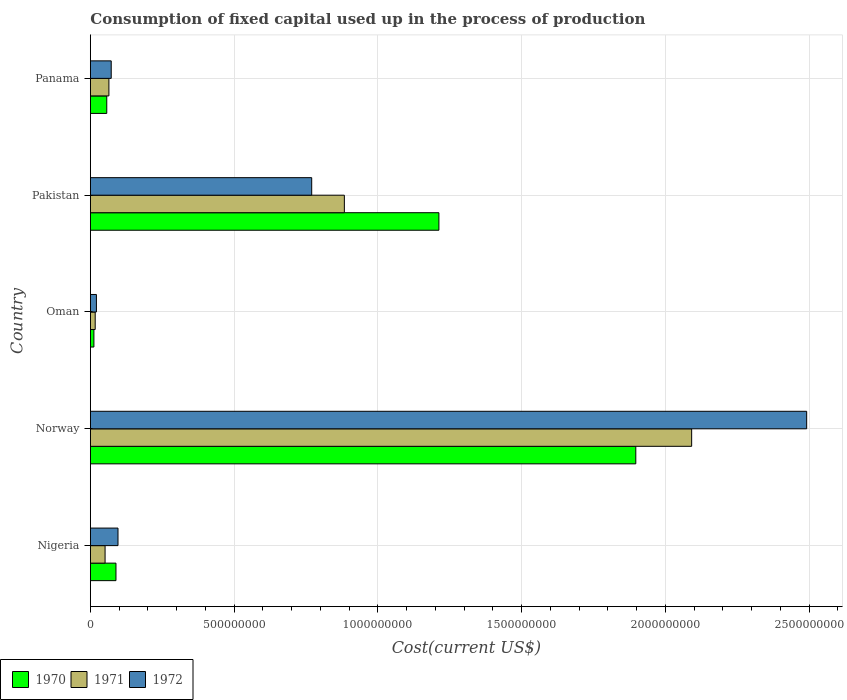How many different coloured bars are there?
Offer a very short reply. 3. How many bars are there on the 3rd tick from the top?
Keep it short and to the point. 3. How many bars are there on the 3rd tick from the bottom?
Your answer should be very brief. 3. What is the label of the 1st group of bars from the top?
Your answer should be compact. Panama. What is the amount consumed in the process of production in 1970 in Panama?
Ensure brevity in your answer.  5.71e+07. Across all countries, what is the maximum amount consumed in the process of production in 1972?
Give a very brief answer. 2.49e+09. Across all countries, what is the minimum amount consumed in the process of production in 1972?
Your response must be concise. 2.11e+07. In which country was the amount consumed in the process of production in 1970 minimum?
Make the answer very short. Oman. What is the total amount consumed in the process of production in 1970 in the graph?
Ensure brevity in your answer.  3.27e+09. What is the difference between the amount consumed in the process of production in 1972 in Norway and that in Panama?
Keep it short and to the point. 2.42e+09. What is the difference between the amount consumed in the process of production in 1971 in Panama and the amount consumed in the process of production in 1970 in Oman?
Make the answer very short. 5.22e+07. What is the average amount consumed in the process of production in 1972 per country?
Give a very brief answer. 6.90e+08. What is the difference between the amount consumed in the process of production in 1971 and amount consumed in the process of production in 1972 in Panama?
Provide a succinct answer. -8.05e+06. In how many countries, is the amount consumed in the process of production in 1971 greater than 800000000 US$?
Make the answer very short. 2. What is the ratio of the amount consumed in the process of production in 1972 in Pakistan to that in Panama?
Offer a terse response. 10.61. Is the difference between the amount consumed in the process of production in 1971 in Nigeria and Oman greater than the difference between the amount consumed in the process of production in 1972 in Nigeria and Oman?
Ensure brevity in your answer.  No. What is the difference between the highest and the second highest amount consumed in the process of production in 1970?
Make the answer very short. 6.85e+08. What is the difference between the highest and the lowest amount consumed in the process of production in 1971?
Offer a very short reply. 2.07e+09. What does the 2nd bar from the top in Norway represents?
Provide a short and direct response. 1971. What does the 3rd bar from the bottom in Norway represents?
Offer a terse response. 1972. Is it the case that in every country, the sum of the amount consumed in the process of production in 1970 and amount consumed in the process of production in 1972 is greater than the amount consumed in the process of production in 1971?
Offer a very short reply. Yes. Are all the bars in the graph horizontal?
Your answer should be very brief. Yes. How many countries are there in the graph?
Your answer should be very brief. 5. What is the difference between two consecutive major ticks on the X-axis?
Keep it short and to the point. 5.00e+08. Where does the legend appear in the graph?
Your response must be concise. Bottom left. How are the legend labels stacked?
Your answer should be very brief. Horizontal. What is the title of the graph?
Offer a terse response. Consumption of fixed capital used up in the process of production. What is the label or title of the X-axis?
Offer a terse response. Cost(current US$). What is the Cost(current US$) of 1970 in Nigeria?
Offer a terse response. 8.90e+07. What is the Cost(current US$) in 1971 in Nigeria?
Your response must be concise. 5.12e+07. What is the Cost(current US$) in 1972 in Nigeria?
Ensure brevity in your answer.  9.61e+07. What is the Cost(current US$) in 1970 in Norway?
Provide a succinct answer. 1.90e+09. What is the Cost(current US$) of 1971 in Norway?
Offer a terse response. 2.09e+09. What is the Cost(current US$) of 1972 in Norway?
Make the answer very short. 2.49e+09. What is the Cost(current US$) of 1970 in Oman?
Your response must be concise. 1.23e+07. What is the Cost(current US$) in 1971 in Oman?
Provide a succinct answer. 1.68e+07. What is the Cost(current US$) in 1972 in Oman?
Keep it short and to the point. 2.11e+07. What is the Cost(current US$) of 1970 in Pakistan?
Offer a terse response. 1.21e+09. What is the Cost(current US$) of 1971 in Pakistan?
Offer a terse response. 8.83e+08. What is the Cost(current US$) in 1972 in Pakistan?
Keep it short and to the point. 7.70e+08. What is the Cost(current US$) in 1970 in Panama?
Make the answer very short. 5.71e+07. What is the Cost(current US$) in 1971 in Panama?
Provide a succinct answer. 6.45e+07. What is the Cost(current US$) in 1972 in Panama?
Provide a succinct answer. 7.25e+07. Across all countries, what is the maximum Cost(current US$) in 1970?
Provide a short and direct response. 1.90e+09. Across all countries, what is the maximum Cost(current US$) of 1971?
Make the answer very short. 2.09e+09. Across all countries, what is the maximum Cost(current US$) in 1972?
Your answer should be very brief. 2.49e+09. Across all countries, what is the minimum Cost(current US$) of 1970?
Offer a very short reply. 1.23e+07. Across all countries, what is the minimum Cost(current US$) of 1971?
Offer a terse response. 1.68e+07. Across all countries, what is the minimum Cost(current US$) in 1972?
Make the answer very short. 2.11e+07. What is the total Cost(current US$) in 1970 in the graph?
Ensure brevity in your answer.  3.27e+09. What is the total Cost(current US$) of 1971 in the graph?
Your answer should be compact. 3.11e+09. What is the total Cost(current US$) in 1972 in the graph?
Offer a very short reply. 3.45e+09. What is the difference between the Cost(current US$) in 1970 in Nigeria and that in Norway?
Provide a succinct answer. -1.81e+09. What is the difference between the Cost(current US$) in 1971 in Nigeria and that in Norway?
Offer a terse response. -2.04e+09. What is the difference between the Cost(current US$) of 1972 in Nigeria and that in Norway?
Your answer should be very brief. -2.40e+09. What is the difference between the Cost(current US$) in 1970 in Nigeria and that in Oman?
Offer a terse response. 7.67e+07. What is the difference between the Cost(current US$) in 1971 in Nigeria and that in Oman?
Make the answer very short. 3.44e+07. What is the difference between the Cost(current US$) in 1972 in Nigeria and that in Oman?
Give a very brief answer. 7.50e+07. What is the difference between the Cost(current US$) in 1970 in Nigeria and that in Pakistan?
Provide a short and direct response. -1.12e+09. What is the difference between the Cost(current US$) in 1971 in Nigeria and that in Pakistan?
Your response must be concise. -8.32e+08. What is the difference between the Cost(current US$) in 1972 in Nigeria and that in Pakistan?
Your response must be concise. -6.74e+08. What is the difference between the Cost(current US$) in 1970 in Nigeria and that in Panama?
Keep it short and to the point. 3.20e+07. What is the difference between the Cost(current US$) in 1971 in Nigeria and that in Panama?
Provide a succinct answer. -1.33e+07. What is the difference between the Cost(current US$) of 1972 in Nigeria and that in Panama?
Offer a very short reply. 2.36e+07. What is the difference between the Cost(current US$) of 1970 in Norway and that in Oman?
Keep it short and to the point. 1.88e+09. What is the difference between the Cost(current US$) in 1971 in Norway and that in Oman?
Your answer should be very brief. 2.07e+09. What is the difference between the Cost(current US$) of 1972 in Norway and that in Oman?
Ensure brevity in your answer.  2.47e+09. What is the difference between the Cost(current US$) of 1970 in Norway and that in Pakistan?
Ensure brevity in your answer.  6.85e+08. What is the difference between the Cost(current US$) of 1971 in Norway and that in Pakistan?
Offer a terse response. 1.21e+09. What is the difference between the Cost(current US$) of 1972 in Norway and that in Pakistan?
Make the answer very short. 1.72e+09. What is the difference between the Cost(current US$) of 1970 in Norway and that in Panama?
Provide a short and direct response. 1.84e+09. What is the difference between the Cost(current US$) of 1971 in Norway and that in Panama?
Provide a succinct answer. 2.03e+09. What is the difference between the Cost(current US$) in 1972 in Norway and that in Panama?
Your response must be concise. 2.42e+09. What is the difference between the Cost(current US$) of 1970 in Oman and that in Pakistan?
Provide a short and direct response. -1.20e+09. What is the difference between the Cost(current US$) in 1971 in Oman and that in Pakistan?
Your answer should be very brief. -8.66e+08. What is the difference between the Cost(current US$) of 1972 in Oman and that in Pakistan?
Provide a succinct answer. -7.49e+08. What is the difference between the Cost(current US$) in 1970 in Oman and that in Panama?
Provide a short and direct response. -4.48e+07. What is the difference between the Cost(current US$) of 1971 in Oman and that in Panama?
Your answer should be very brief. -4.76e+07. What is the difference between the Cost(current US$) in 1972 in Oman and that in Panama?
Give a very brief answer. -5.15e+07. What is the difference between the Cost(current US$) of 1970 in Pakistan and that in Panama?
Keep it short and to the point. 1.16e+09. What is the difference between the Cost(current US$) of 1971 in Pakistan and that in Panama?
Provide a short and direct response. 8.19e+08. What is the difference between the Cost(current US$) of 1972 in Pakistan and that in Panama?
Offer a terse response. 6.97e+08. What is the difference between the Cost(current US$) in 1970 in Nigeria and the Cost(current US$) in 1971 in Norway?
Provide a short and direct response. -2.00e+09. What is the difference between the Cost(current US$) in 1970 in Nigeria and the Cost(current US$) in 1972 in Norway?
Keep it short and to the point. -2.40e+09. What is the difference between the Cost(current US$) of 1971 in Nigeria and the Cost(current US$) of 1972 in Norway?
Make the answer very short. -2.44e+09. What is the difference between the Cost(current US$) in 1970 in Nigeria and the Cost(current US$) in 1971 in Oman?
Your response must be concise. 7.22e+07. What is the difference between the Cost(current US$) of 1970 in Nigeria and the Cost(current US$) of 1972 in Oman?
Ensure brevity in your answer.  6.79e+07. What is the difference between the Cost(current US$) of 1971 in Nigeria and the Cost(current US$) of 1972 in Oman?
Your answer should be very brief. 3.01e+07. What is the difference between the Cost(current US$) in 1970 in Nigeria and the Cost(current US$) in 1971 in Pakistan?
Give a very brief answer. -7.94e+08. What is the difference between the Cost(current US$) of 1970 in Nigeria and the Cost(current US$) of 1972 in Pakistan?
Your answer should be very brief. -6.81e+08. What is the difference between the Cost(current US$) in 1971 in Nigeria and the Cost(current US$) in 1972 in Pakistan?
Your answer should be very brief. -7.19e+08. What is the difference between the Cost(current US$) of 1970 in Nigeria and the Cost(current US$) of 1971 in Panama?
Your answer should be very brief. 2.45e+07. What is the difference between the Cost(current US$) of 1970 in Nigeria and the Cost(current US$) of 1972 in Panama?
Your response must be concise. 1.65e+07. What is the difference between the Cost(current US$) of 1971 in Nigeria and the Cost(current US$) of 1972 in Panama?
Your response must be concise. -2.13e+07. What is the difference between the Cost(current US$) of 1970 in Norway and the Cost(current US$) of 1971 in Oman?
Your answer should be compact. 1.88e+09. What is the difference between the Cost(current US$) in 1970 in Norway and the Cost(current US$) in 1972 in Oman?
Your response must be concise. 1.88e+09. What is the difference between the Cost(current US$) in 1971 in Norway and the Cost(current US$) in 1972 in Oman?
Ensure brevity in your answer.  2.07e+09. What is the difference between the Cost(current US$) of 1970 in Norway and the Cost(current US$) of 1971 in Pakistan?
Your answer should be compact. 1.01e+09. What is the difference between the Cost(current US$) in 1970 in Norway and the Cost(current US$) in 1972 in Pakistan?
Your answer should be compact. 1.13e+09. What is the difference between the Cost(current US$) in 1971 in Norway and the Cost(current US$) in 1972 in Pakistan?
Give a very brief answer. 1.32e+09. What is the difference between the Cost(current US$) of 1970 in Norway and the Cost(current US$) of 1971 in Panama?
Your answer should be very brief. 1.83e+09. What is the difference between the Cost(current US$) of 1970 in Norway and the Cost(current US$) of 1972 in Panama?
Keep it short and to the point. 1.82e+09. What is the difference between the Cost(current US$) in 1971 in Norway and the Cost(current US$) in 1972 in Panama?
Keep it short and to the point. 2.02e+09. What is the difference between the Cost(current US$) in 1970 in Oman and the Cost(current US$) in 1971 in Pakistan?
Provide a short and direct response. -8.71e+08. What is the difference between the Cost(current US$) in 1970 in Oman and the Cost(current US$) in 1972 in Pakistan?
Your response must be concise. -7.57e+08. What is the difference between the Cost(current US$) in 1971 in Oman and the Cost(current US$) in 1972 in Pakistan?
Ensure brevity in your answer.  -7.53e+08. What is the difference between the Cost(current US$) of 1970 in Oman and the Cost(current US$) of 1971 in Panama?
Provide a short and direct response. -5.22e+07. What is the difference between the Cost(current US$) of 1970 in Oman and the Cost(current US$) of 1972 in Panama?
Your answer should be compact. -6.02e+07. What is the difference between the Cost(current US$) in 1971 in Oman and the Cost(current US$) in 1972 in Panama?
Your response must be concise. -5.57e+07. What is the difference between the Cost(current US$) in 1970 in Pakistan and the Cost(current US$) in 1971 in Panama?
Give a very brief answer. 1.15e+09. What is the difference between the Cost(current US$) in 1970 in Pakistan and the Cost(current US$) in 1972 in Panama?
Provide a short and direct response. 1.14e+09. What is the difference between the Cost(current US$) in 1971 in Pakistan and the Cost(current US$) in 1972 in Panama?
Give a very brief answer. 8.11e+08. What is the average Cost(current US$) of 1970 per country?
Provide a short and direct response. 6.53e+08. What is the average Cost(current US$) in 1971 per country?
Provide a succinct answer. 6.21e+08. What is the average Cost(current US$) in 1972 per country?
Your response must be concise. 6.90e+08. What is the difference between the Cost(current US$) of 1970 and Cost(current US$) of 1971 in Nigeria?
Your response must be concise. 3.78e+07. What is the difference between the Cost(current US$) of 1970 and Cost(current US$) of 1972 in Nigeria?
Your answer should be very brief. -7.11e+06. What is the difference between the Cost(current US$) of 1971 and Cost(current US$) of 1972 in Nigeria?
Provide a short and direct response. -4.49e+07. What is the difference between the Cost(current US$) in 1970 and Cost(current US$) in 1971 in Norway?
Your answer should be very brief. -1.94e+08. What is the difference between the Cost(current US$) in 1970 and Cost(current US$) in 1972 in Norway?
Keep it short and to the point. -5.94e+08. What is the difference between the Cost(current US$) of 1971 and Cost(current US$) of 1972 in Norway?
Your answer should be very brief. -4.00e+08. What is the difference between the Cost(current US$) in 1970 and Cost(current US$) in 1971 in Oman?
Provide a succinct answer. -4.53e+06. What is the difference between the Cost(current US$) of 1970 and Cost(current US$) of 1972 in Oman?
Ensure brevity in your answer.  -8.78e+06. What is the difference between the Cost(current US$) in 1971 and Cost(current US$) in 1972 in Oman?
Keep it short and to the point. -4.25e+06. What is the difference between the Cost(current US$) in 1970 and Cost(current US$) in 1971 in Pakistan?
Offer a terse response. 3.29e+08. What is the difference between the Cost(current US$) in 1970 and Cost(current US$) in 1972 in Pakistan?
Your answer should be very brief. 4.42e+08. What is the difference between the Cost(current US$) in 1971 and Cost(current US$) in 1972 in Pakistan?
Offer a terse response. 1.14e+08. What is the difference between the Cost(current US$) in 1970 and Cost(current US$) in 1971 in Panama?
Your response must be concise. -7.42e+06. What is the difference between the Cost(current US$) in 1970 and Cost(current US$) in 1972 in Panama?
Offer a terse response. -1.55e+07. What is the difference between the Cost(current US$) of 1971 and Cost(current US$) of 1972 in Panama?
Your answer should be very brief. -8.05e+06. What is the ratio of the Cost(current US$) of 1970 in Nigeria to that in Norway?
Your answer should be compact. 0.05. What is the ratio of the Cost(current US$) in 1971 in Nigeria to that in Norway?
Keep it short and to the point. 0.02. What is the ratio of the Cost(current US$) of 1972 in Nigeria to that in Norway?
Provide a succinct answer. 0.04. What is the ratio of the Cost(current US$) in 1970 in Nigeria to that in Oman?
Provide a succinct answer. 7.24. What is the ratio of the Cost(current US$) of 1971 in Nigeria to that in Oman?
Make the answer very short. 3.04. What is the ratio of the Cost(current US$) in 1972 in Nigeria to that in Oman?
Provide a succinct answer. 4.56. What is the ratio of the Cost(current US$) in 1970 in Nigeria to that in Pakistan?
Provide a short and direct response. 0.07. What is the ratio of the Cost(current US$) in 1971 in Nigeria to that in Pakistan?
Ensure brevity in your answer.  0.06. What is the ratio of the Cost(current US$) in 1972 in Nigeria to that in Pakistan?
Offer a very short reply. 0.12. What is the ratio of the Cost(current US$) in 1970 in Nigeria to that in Panama?
Give a very brief answer. 1.56. What is the ratio of the Cost(current US$) of 1971 in Nigeria to that in Panama?
Provide a succinct answer. 0.79. What is the ratio of the Cost(current US$) of 1972 in Nigeria to that in Panama?
Provide a short and direct response. 1.33. What is the ratio of the Cost(current US$) of 1970 in Norway to that in Oman?
Your answer should be very brief. 154.19. What is the ratio of the Cost(current US$) in 1971 in Norway to that in Oman?
Your response must be concise. 124.24. What is the ratio of the Cost(current US$) in 1972 in Norway to that in Oman?
Ensure brevity in your answer.  118.17. What is the ratio of the Cost(current US$) in 1970 in Norway to that in Pakistan?
Your answer should be compact. 1.56. What is the ratio of the Cost(current US$) in 1971 in Norway to that in Pakistan?
Offer a terse response. 2.37. What is the ratio of the Cost(current US$) of 1972 in Norway to that in Pakistan?
Your answer should be compact. 3.24. What is the ratio of the Cost(current US$) of 1970 in Norway to that in Panama?
Your answer should be very brief. 33.24. What is the ratio of the Cost(current US$) of 1971 in Norway to that in Panama?
Offer a terse response. 32.43. What is the ratio of the Cost(current US$) in 1972 in Norway to that in Panama?
Provide a short and direct response. 34.35. What is the ratio of the Cost(current US$) of 1970 in Oman to that in Pakistan?
Offer a terse response. 0.01. What is the ratio of the Cost(current US$) in 1971 in Oman to that in Pakistan?
Give a very brief answer. 0.02. What is the ratio of the Cost(current US$) in 1972 in Oman to that in Pakistan?
Ensure brevity in your answer.  0.03. What is the ratio of the Cost(current US$) in 1970 in Oman to that in Panama?
Keep it short and to the point. 0.22. What is the ratio of the Cost(current US$) of 1971 in Oman to that in Panama?
Your answer should be compact. 0.26. What is the ratio of the Cost(current US$) of 1972 in Oman to that in Panama?
Your answer should be very brief. 0.29. What is the ratio of the Cost(current US$) in 1970 in Pakistan to that in Panama?
Provide a succinct answer. 21.24. What is the ratio of the Cost(current US$) in 1971 in Pakistan to that in Panama?
Provide a short and direct response. 13.7. What is the ratio of the Cost(current US$) in 1972 in Pakistan to that in Panama?
Offer a very short reply. 10.61. What is the difference between the highest and the second highest Cost(current US$) in 1970?
Your answer should be very brief. 6.85e+08. What is the difference between the highest and the second highest Cost(current US$) in 1971?
Make the answer very short. 1.21e+09. What is the difference between the highest and the second highest Cost(current US$) of 1972?
Offer a very short reply. 1.72e+09. What is the difference between the highest and the lowest Cost(current US$) of 1970?
Your answer should be very brief. 1.88e+09. What is the difference between the highest and the lowest Cost(current US$) in 1971?
Ensure brevity in your answer.  2.07e+09. What is the difference between the highest and the lowest Cost(current US$) of 1972?
Your response must be concise. 2.47e+09. 